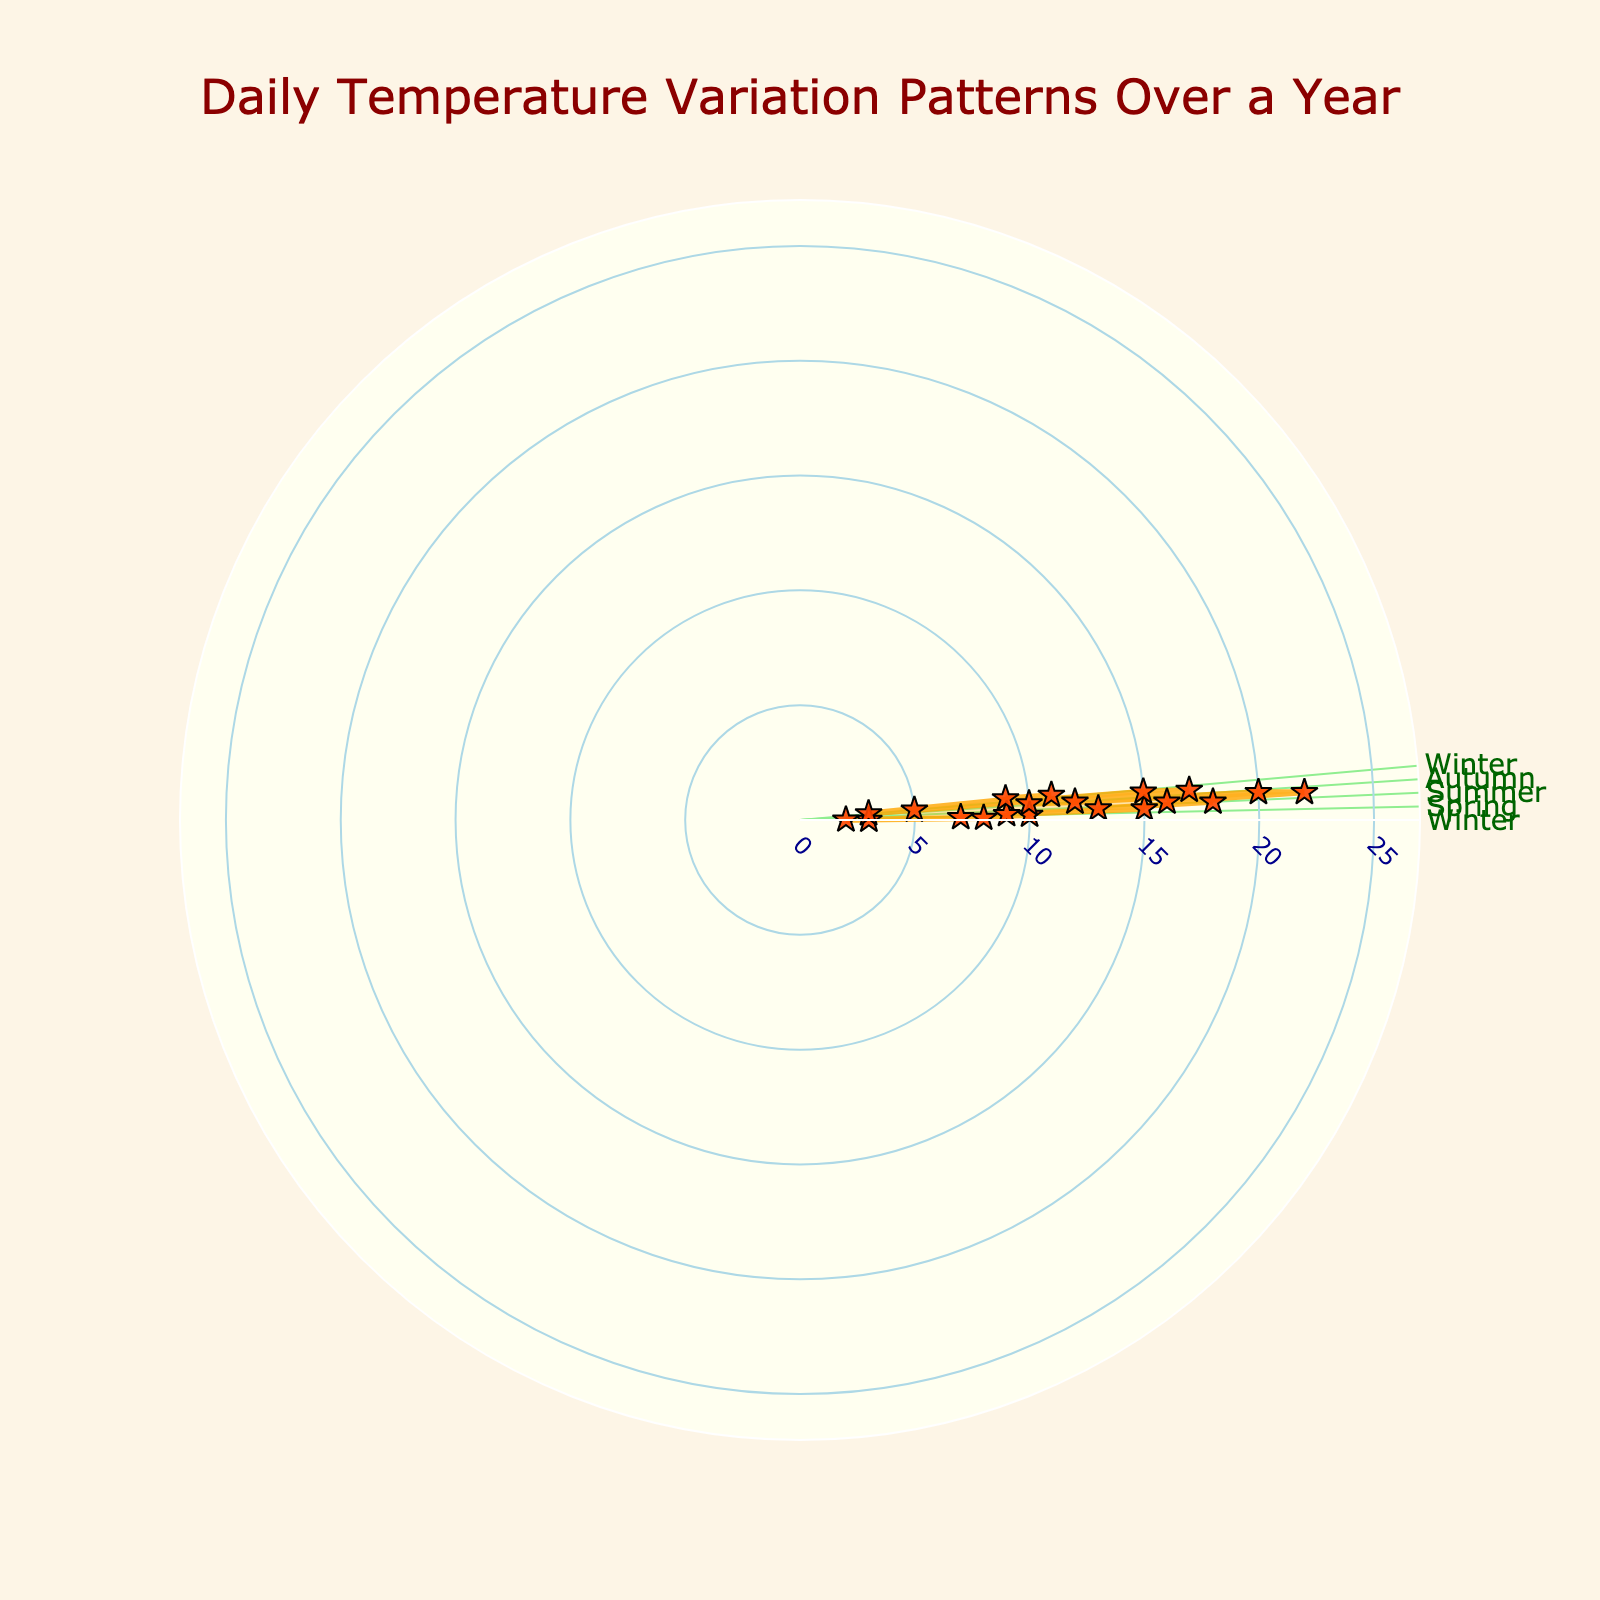What is the title of the rose chart? The title is usually located at the top of the chart and provides a summary of what the chart represents.
Answer: Daily Temperature Variation Patterns Over a Year How many seasons are indicated around the rose chart? The rose chart typically segments data into parts, and different sections might represent different time periods or seasons. Count the labeled segments.
Answer: Four What is the highest temperature recorded in the rose chart? Examine the length of the longest 'arm' of the rose chart, as it represents the highest value.
Answer: 22 Which time of year shows the greatest temperature variation? Look at the differences between the maximum and minimum radial distances for each season. Larger differences indicate greater variation.
Answer: Summer What color represents the temperature data points on the rose chart? Identify the color of the markers that denote data points on the rose chart.
Answer: Red-Orange How is the data visually connected in the rose chart? Look at how the data points are connected; this is often shown by lines connecting the markers.
Answer: Lines and Markers Is the temperature higher overall in winter or autumn? Compare the radial distances (temperature values) for points during winter and autumn. Summarize where the points are generally higher.
Answer: Autumn What is the shape created by connecting the temperature points on the rose chart? Observe the overall form made by connecting the outer points. This often tells about the general pattern or trend.
Answer: Star shape In which month does the temperature at 12:00 PM reach its peak? Refer to the specific data points marked as 12:00 PM and identify the month with the highest temperature reading.
Answer: July What happens to the temperature from 00:00 to 12:00 during spring and autumn? Compare the temperature readings at 00:00 and 12:00 for spring and autumn, and note the changes.
Answer: It increases in both seasons 